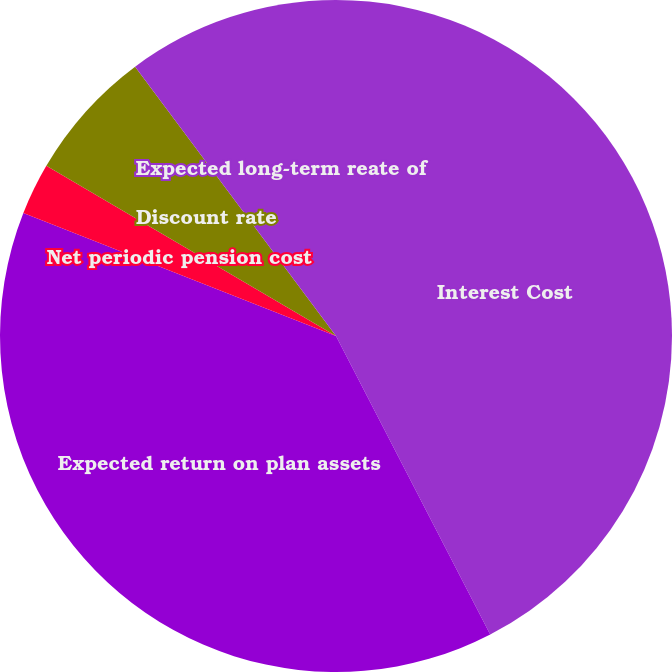Convert chart to OTSL. <chart><loc_0><loc_0><loc_500><loc_500><pie_chart><fcel>Interest Cost<fcel>Expected return on plan assets<fcel>Net periodic pension cost<fcel>Discount rate<fcel>Expected long-term reate of<nl><fcel>42.41%<fcel>38.56%<fcel>2.49%<fcel>6.34%<fcel>10.2%<nl></chart> 